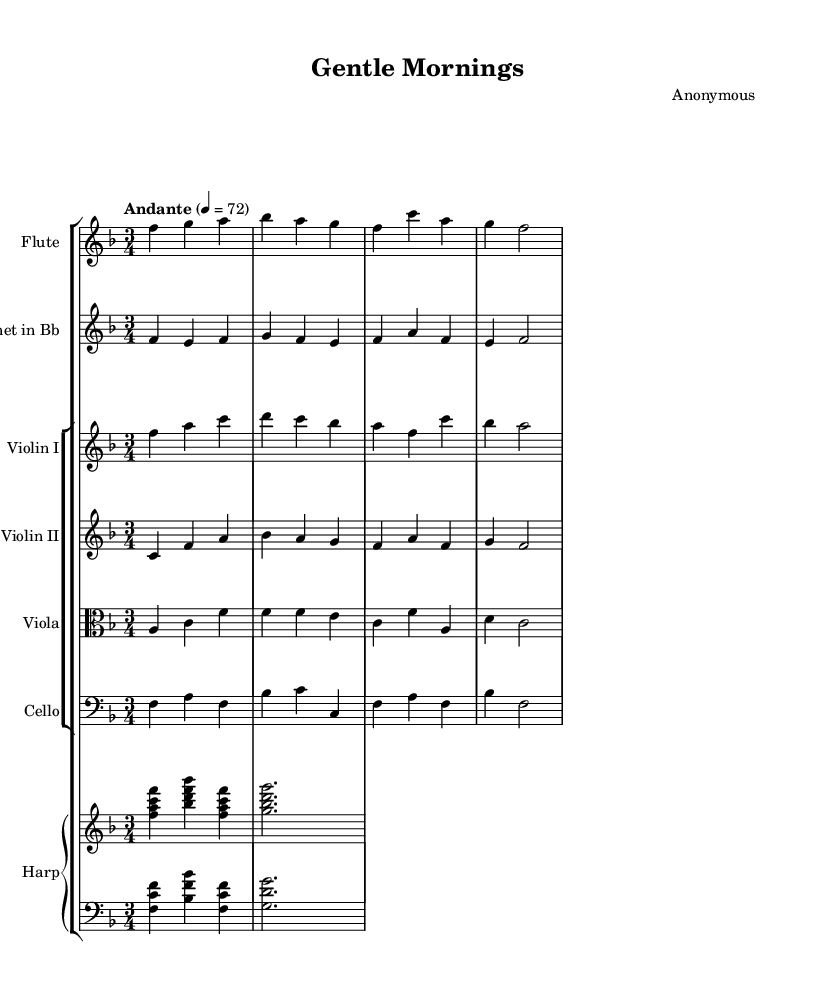What is the key signature of this music? The key signature is F major, which has one flat (B flat). This can be determined by looking for the key signature indicated at the beginning of the staff, where it shows the B flat symbol.
Answer: F major What is the time signature of this music? The time signature is 3/4, indicated at the beginning of the score. This means there are three beats in each measure, and the quarter note gets one beat, as represented by the numbers in the time signature.
Answer: 3/4 What is the tempo marking given for this piece? The tempo marking is "Andante," which indicates a moderately slow tempo. This can be found below the title and is often described in Italian terms that define the mood or speed of the composition.
Answer: Andante How many measures are there in this piece? There are 14 measures in total. The measures can be counted by looking at the vertical lines that separate the groups of notes throughout the sheet music.
Answer: 14 Which instruments are featured in this orchestral composition? The instruments featured are Flute, Clarinet, Violin I, Violin II, Viola, Cello, and Harp. These instruments are listed at the beginning of each staff in the score, identifying the various parts played in the piece.
Answer: Flute, Clarinet, Violin I, Violin II, Viola, Cello, Harp What can the overall mood of this composition be described as? The overall mood of the composition can be described as calming and serene. This can be inferred from the gentle tempo, the use of a major key, and the flowing melodic lines typical of Romantic music aimed at evoking the beauty of simple, everyday moments.
Answer: Calming 